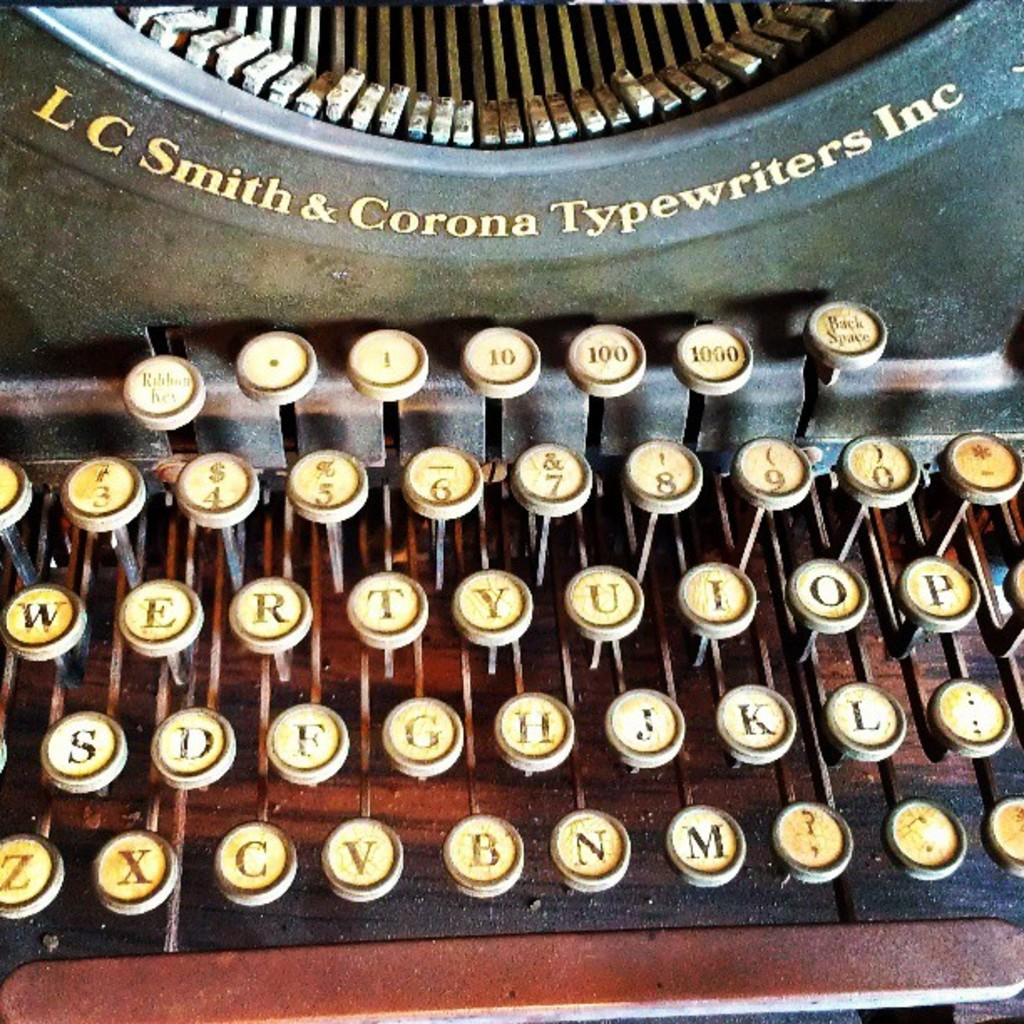Provide a one-sentence caption for the provided image. The vintage typewriter has the name LC Smith & Corona Typewriters Inc on it. 